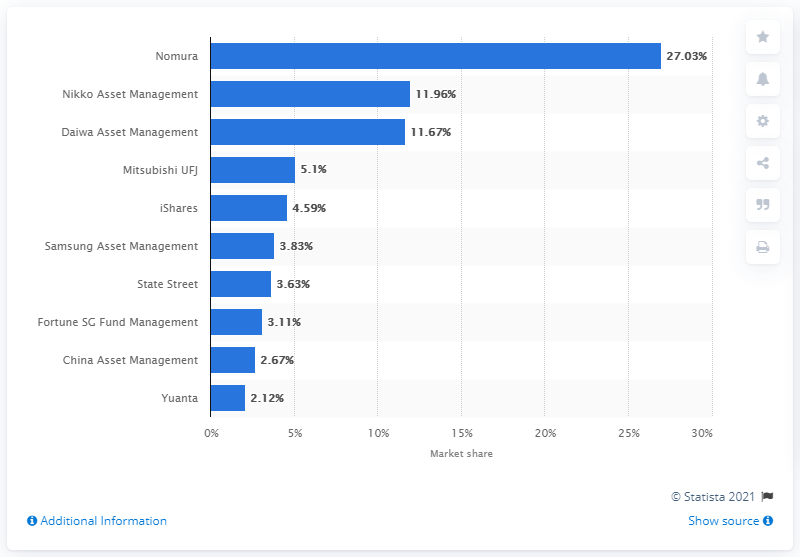Identify some key points in this picture. As of December 2018, Nomura's market share was 27.03%. Nomura was the largest ETP provider in the Asia Pacific region as of December 2018. 